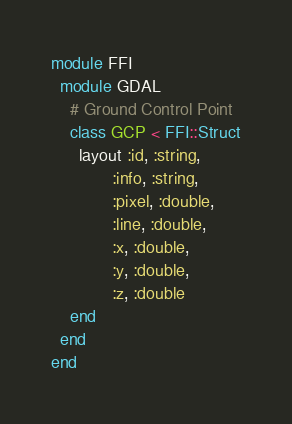Convert code to text. <code><loc_0><loc_0><loc_500><loc_500><_Ruby_>
module FFI
  module GDAL
    # Ground Control Point
    class GCP < FFI::Struct
      layout :id, :string,
             :info, :string,
             :pixel, :double,
             :line, :double,
             :x, :double,
             :y, :double,
             :z, :double
    end
  end
end
</code> 